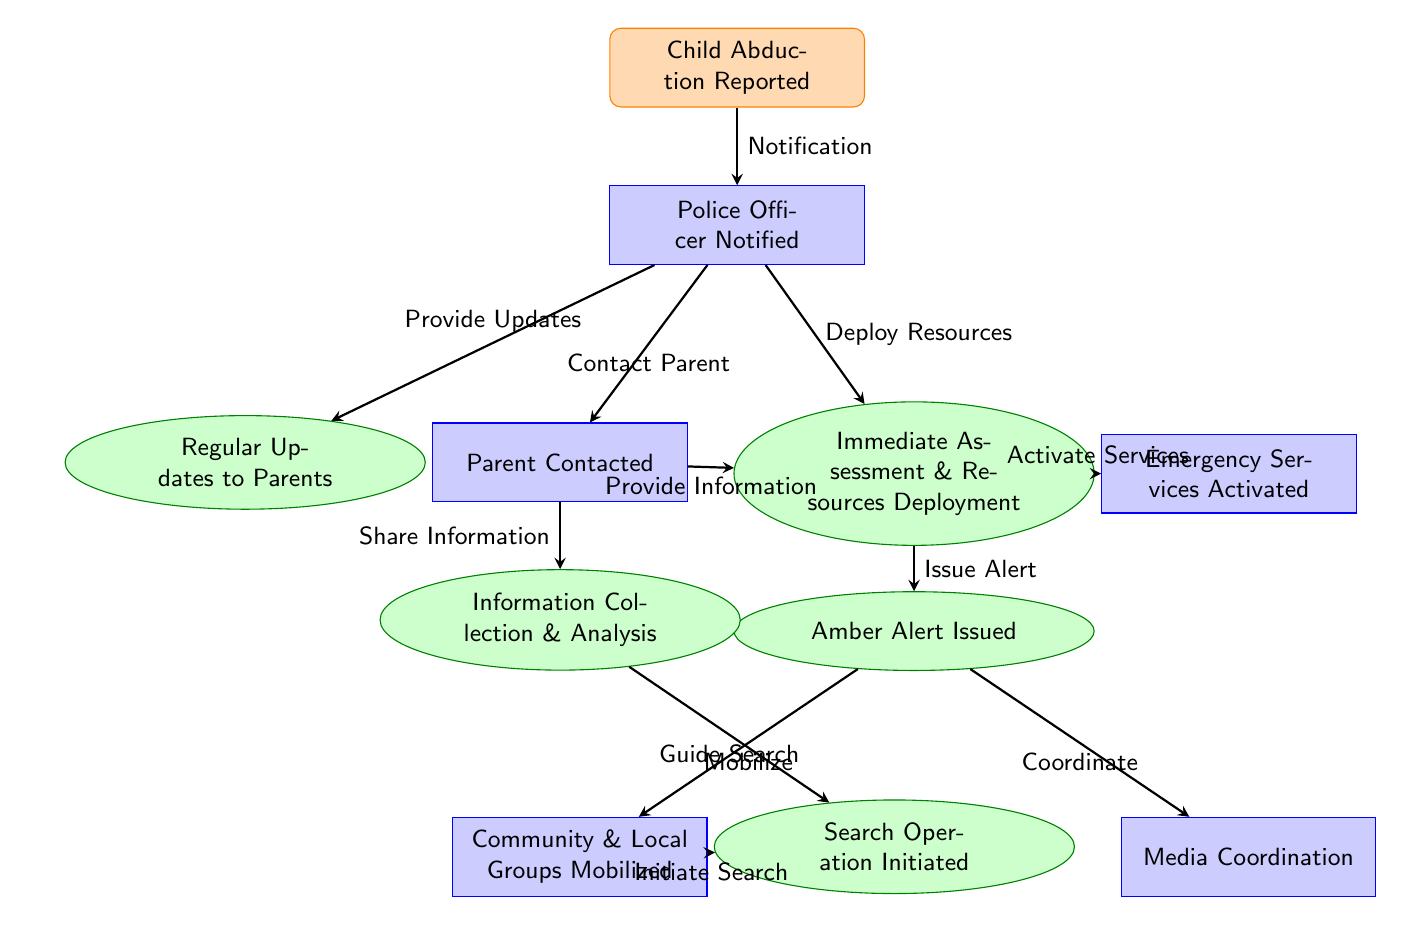What event initiates the flowchart? The flowchart begins with the event "Child Abduction Reported," which is represented as the first node in the diagram.
Answer: Child Abduction Reported Who is notified after the child abduction is reported? Following the event of a reported child abduction, the next node shows that a "Police Officer Notified" connects to it as the immediate action taken.
Answer: Police Officer Notified How many roles are depicted in the flowchart? There are four roles indicated in the diagram: Police Officer, Parent, Community & Local Groups, and Media Coordination, making a total of four.
Answer: Four What action is taken after deploying resources? After the "Immediate Assessment & Resources Deployment," the action taken next is to "Issue Alert," indicating that an Amber Alert is initiated.
Answer: Amber Alert Issued What is the first step taken by the parent contacted? The first action outlined for the contacted parent is "Provide Information" to the police officer, establishing the role they play in the child abduction case.
Answer: Provide Information What connects "Amber Alert Issued" to "Search Operation Initiated"? The action that connects these two nodes is "Mobilize," which signifies the mobilization of community and local groups for search efforts.
Answer: Mobilize What role is responsible for guiding the search with information collected? The role responsible for guiding the search operation based on previous interactions is the "Parent," who shares information to aid the search efforts.
Answer: Parent Which action involves coordinating with media? The "Media Coordination" role is connected by the action labeled "Coordinate," which indicates collaboration with media to spread awareness.
Answer: Media Coordination What action is performed by emergency services activated? The emergency services activated perform the action of "Activate Services," indicating that they begin their specific role in the response to the abduction.
Answer: Activate Services 